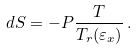<formula> <loc_0><loc_0><loc_500><loc_500>d S = - P \frac { T } { T _ { r } ( \varepsilon _ { x } ) } \, .</formula> 